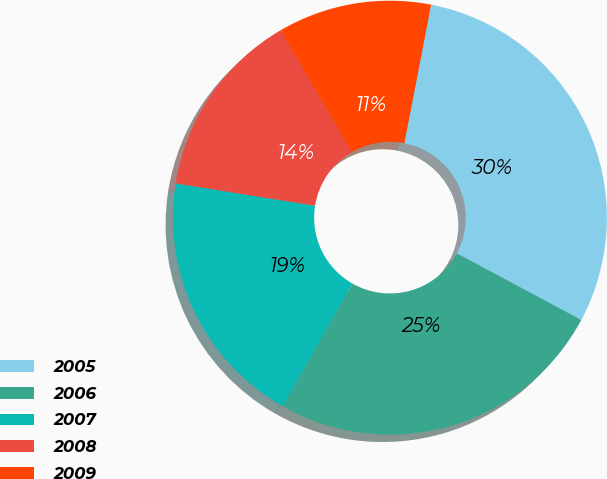Convert chart to OTSL. <chart><loc_0><loc_0><loc_500><loc_500><pie_chart><fcel>2005<fcel>2006<fcel>2007<fcel>2008<fcel>2009<nl><fcel>29.78%<fcel>25.42%<fcel>19.29%<fcel>14.07%<fcel>11.44%<nl></chart> 